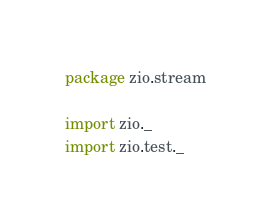Convert code to text. <code><loc_0><loc_0><loc_500><loc_500><_Scala_>package zio.stream

import zio._
import zio.test._</code> 